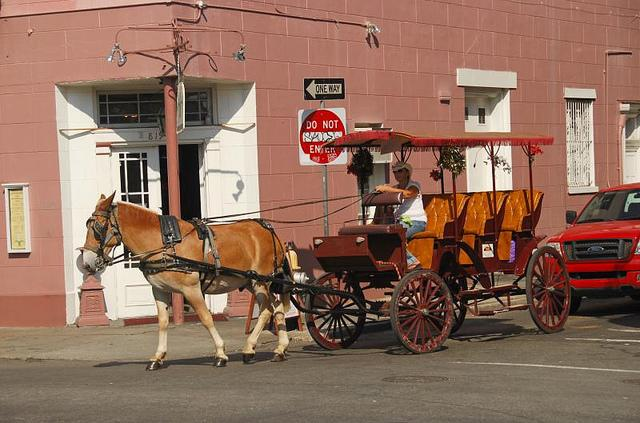What is the person in the carriage most likely looking for? passengers 